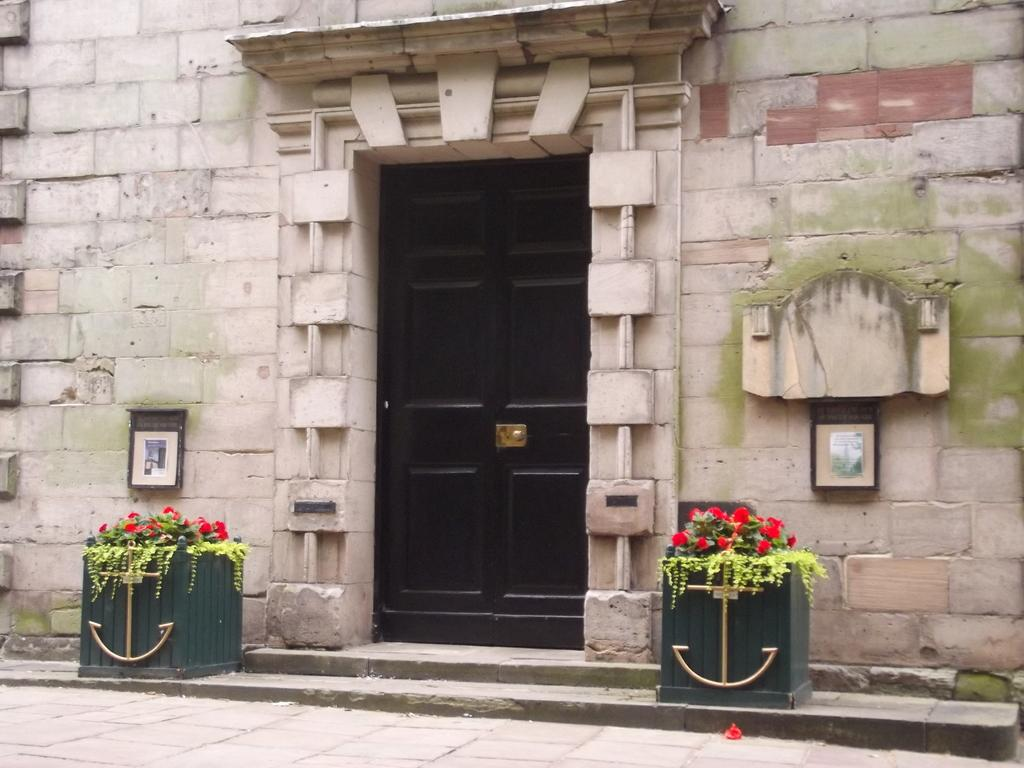What type of plants are in the boxes at the bottom of the image? There are plants with flowers in the boxes at the bottom of the image. What can be seen in the background of the image? There is a road visible in the image. What architectural features are present in the image? There are doors in the image. What is on the wall in the image? There are objects on the wall in the image. Can you describe the man holding the cat with a locket around its neck in the image? There is no man, cat, or locket present in the image. 